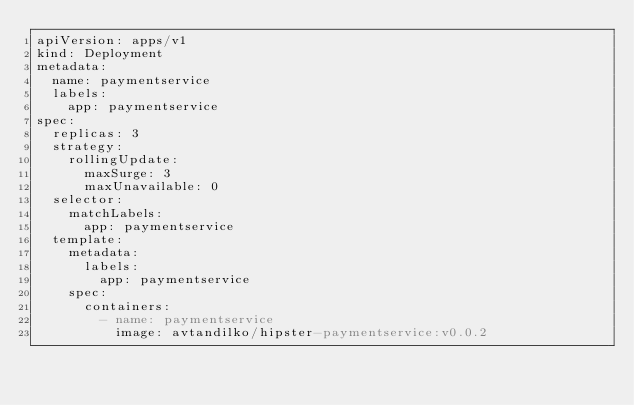<code> <loc_0><loc_0><loc_500><loc_500><_YAML_>apiVersion: apps/v1
kind: Deployment
metadata:
  name: paymentservice
  labels:
    app: paymentservice
spec:
  replicas: 3
  strategy:
    rollingUpdate:
      maxSurge: 3
      maxUnavailable: 0
  selector:
    matchLabels:
      app: paymentservice
  template:
    metadata:
      labels:
        app: paymentservice
    spec:
      containers:
        - name: paymentservice
          image: avtandilko/hipster-paymentservice:v0.0.2</code> 